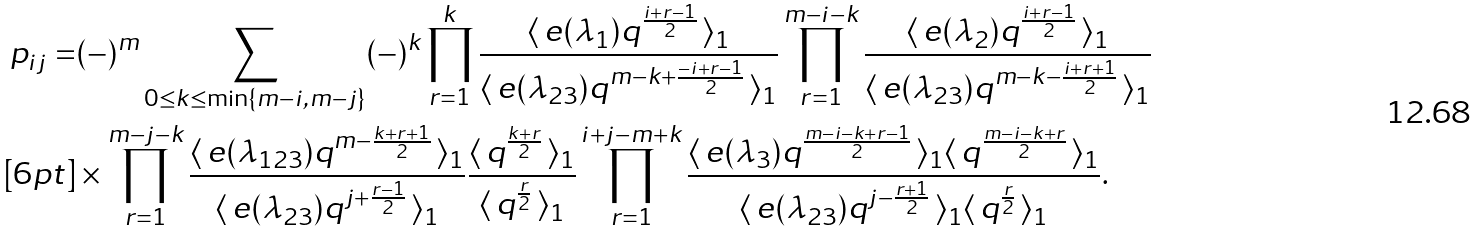<formula> <loc_0><loc_0><loc_500><loc_500>p _ { i j } = & ( - ) ^ { m } \sum _ { 0 \leq k \leq \min \{ m - i , m - j \} } ( - ) ^ { k } \prod _ { r = 1 } ^ { k } \frac { \langle \, e ( \lambda _ { 1 } ) q ^ { \frac { i + r - 1 } { 2 } } \, \rangle _ { 1 } } { \langle \, e ( \lambda _ { 2 3 } ) q ^ { m - k + \frac { - i + r - 1 } { 2 } } \, \rangle _ { 1 } } \prod _ { r = 1 } ^ { m - i - k } \frac { \langle \, e ( \lambda _ { 2 } ) q ^ { \frac { i + r - 1 } { 2 } } \, \rangle _ { 1 } } { \langle \, e ( \lambda _ { 2 3 } ) q ^ { m - k - \frac { i + r + 1 } { 2 } } \, \rangle _ { 1 } } \\ [ 6 p t ] & \times \prod _ { r = 1 } ^ { m - j - k } \frac { \langle \, e ( \lambda _ { 1 2 3 } ) q ^ { m - \frac { k + r + 1 } { 2 } } \, \rangle _ { 1 } } { \langle \, e ( \lambda _ { 2 3 } ) q ^ { j + \frac { r - 1 } { 2 } } \, \rangle _ { 1 } } \frac { \langle \, q ^ { \frac { k + r } { 2 } } \, \rangle _ { 1 } } { \langle \, q ^ { \frac { r } { 2 } } \, \rangle _ { 1 } } \prod _ { r = 1 } ^ { i + j - m + k } \frac { \langle \, e ( \lambda _ { 3 } ) q ^ { \frac { m - i - k + r - 1 } { 2 } } \, \rangle _ { 1 } \langle \, q ^ { \frac { m - i - k + r } { 2 } } \, \rangle _ { 1 } } { \langle \, e ( \lambda _ { 2 3 } ) q ^ { j - \frac { r + 1 } { 2 } } \, \rangle _ { 1 } \langle \, q ^ { \frac { r } { 2 } } \, \rangle _ { 1 } } .</formula> 